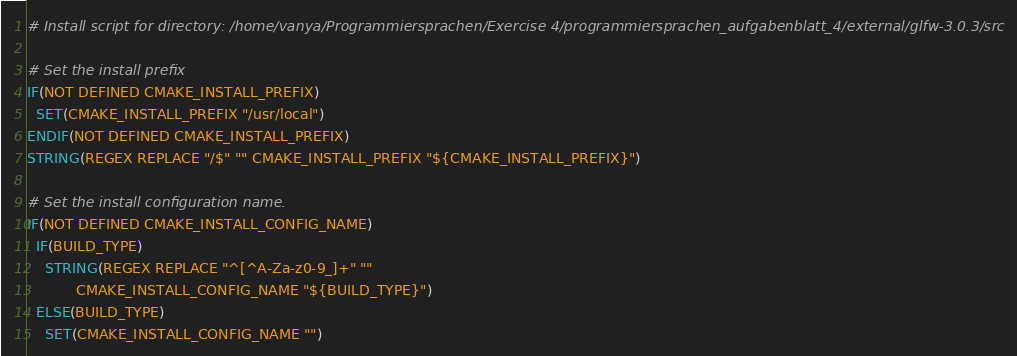Convert code to text. <code><loc_0><loc_0><loc_500><loc_500><_CMake_># Install script for directory: /home/vanya/Programmiersprachen/Exercise 4/programmiersprachen_aufgabenblatt_4/external/glfw-3.0.3/src

# Set the install prefix
IF(NOT DEFINED CMAKE_INSTALL_PREFIX)
  SET(CMAKE_INSTALL_PREFIX "/usr/local")
ENDIF(NOT DEFINED CMAKE_INSTALL_PREFIX)
STRING(REGEX REPLACE "/$" "" CMAKE_INSTALL_PREFIX "${CMAKE_INSTALL_PREFIX}")

# Set the install configuration name.
IF(NOT DEFINED CMAKE_INSTALL_CONFIG_NAME)
  IF(BUILD_TYPE)
    STRING(REGEX REPLACE "^[^A-Za-z0-9_]+" ""
           CMAKE_INSTALL_CONFIG_NAME "${BUILD_TYPE}")
  ELSE(BUILD_TYPE)
    SET(CMAKE_INSTALL_CONFIG_NAME "")</code> 